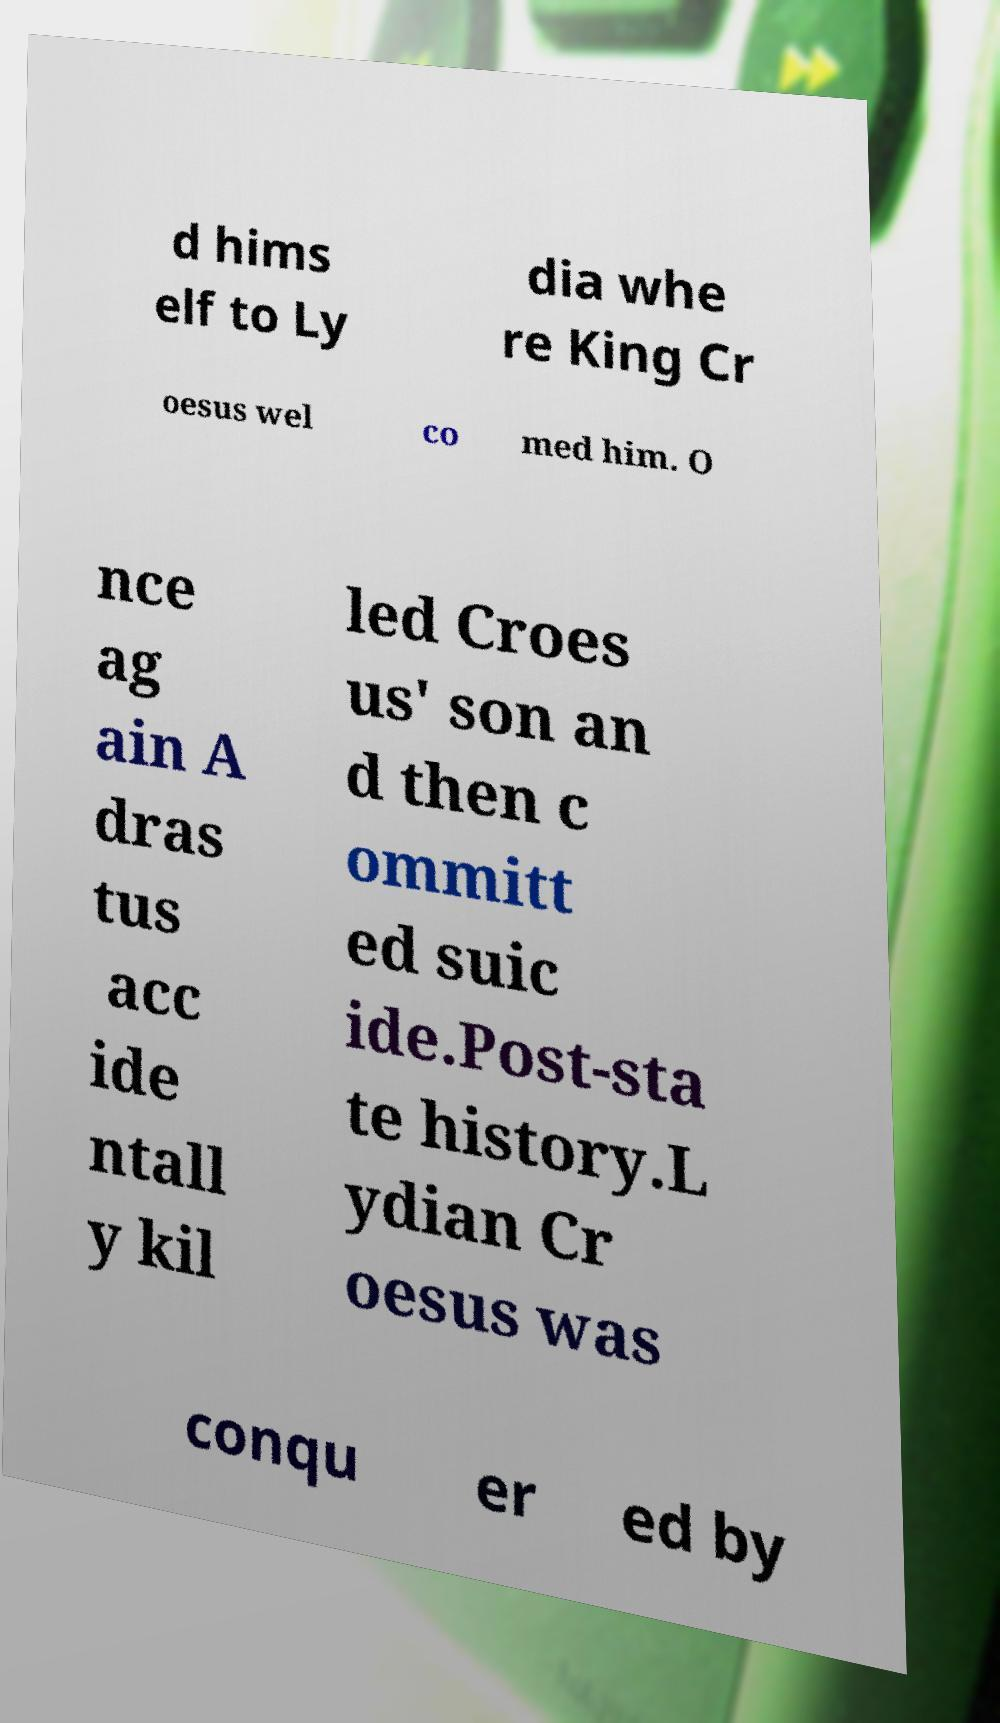What messages or text are displayed in this image? I need them in a readable, typed format. d hims elf to Ly dia whe re King Cr oesus wel co med him. O nce ag ain A dras tus acc ide ntall y kil led Croes us' son an d then c ommitt ed suic ide.Post-sta te history.L ydian Cr oesus was conqu er ed by 